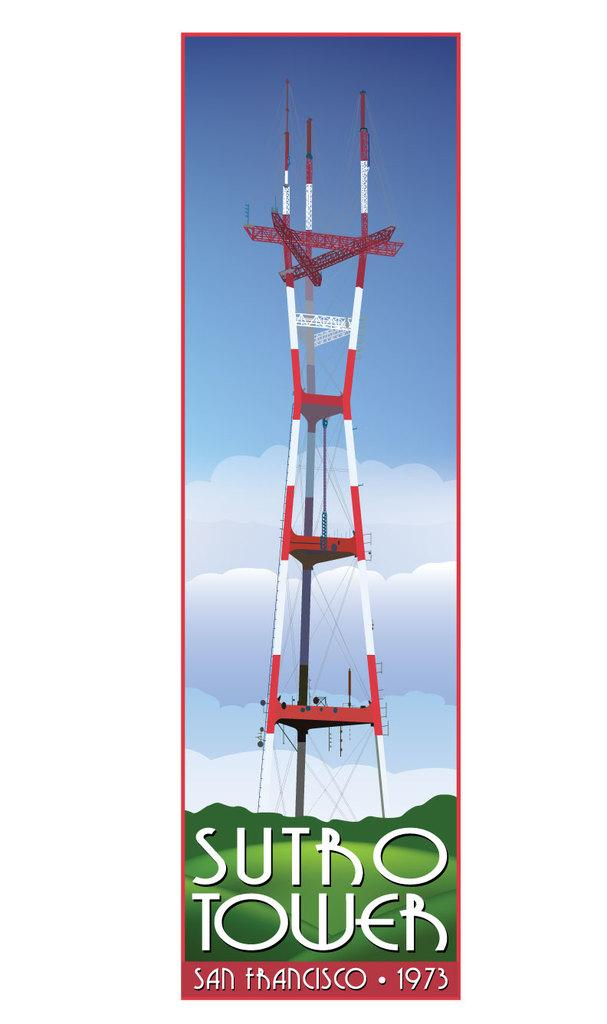Provide a one-sentence caption for the provided image. A cell phone tower titled Sutro Tower San Francisco 1973. 